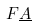<formula> <loc_0><loc_0><loc_500><loc_500>F \underline { A }</formula> 